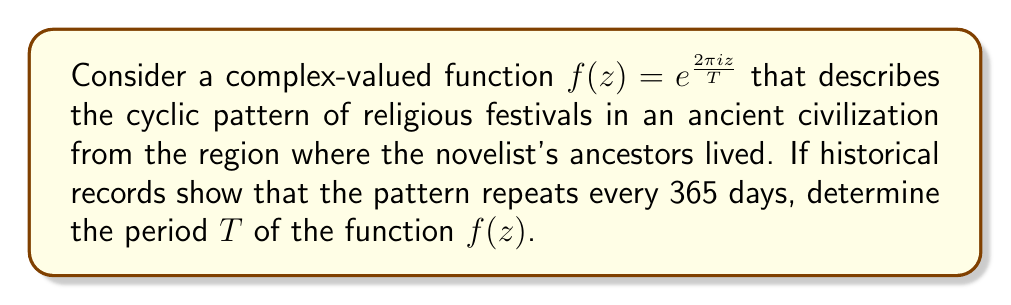Show me your answer to this math problem. To solve this problem, we need to understand the concept of periodicity in complex-valued functions and relate it to the given historical context.

1) For a complex-valued function $f(z)$, the period $T$ is defined as the smallest positive real number such that:

   $f(z + T) = f(z)$ for all $z$

2) In our case, $f(z) = e^{\frac{2\pi i z}{T}}$

3) We know that $e^{2\pi i} = 1$, which means the exponential function completes one full rotation around the complex plane when its argument is $2\pi i$.

4) For our function to repeat, we need:

   $\frac{2\pi i (z + T)}{T} = \frac{2\pi i z}{T} + 2\pi i$

5) This equality holds when $T = 365$, as given in the historical context.

6) To verify:

   $f(z + 365) = e^{\frac{2\pi i (z + 365)}{365}} = e^{\frac{2\pi i z}{365}} \cdot e^{\frac{2\pi i \cdot 365}{365}} = e^{\frac{2\pi i z}{365}} \cdot e^{2\pi i} = e^{\frac{2\pi i z}{365}} \cdot 1 = f(z)$

Therefore, the period of the function is indeed 365 days, matching the historical record of the ancient civilization's festival cycle.
Answer: $T = 365$ days 